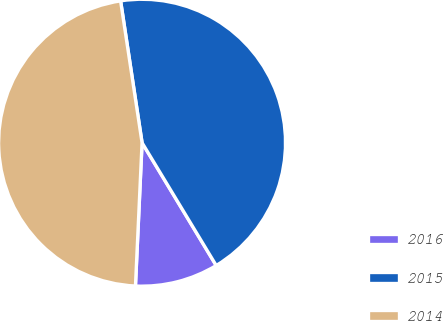Convert chart to OTSL. <chart><loc_0><loc_0><loc_500><loc_500><pie_chart><fcel>2016<fcel>2015<fcel>2014<nl><fcel>9.38%<fcel>43.75%<fcel>46.88%<nl></chart> 